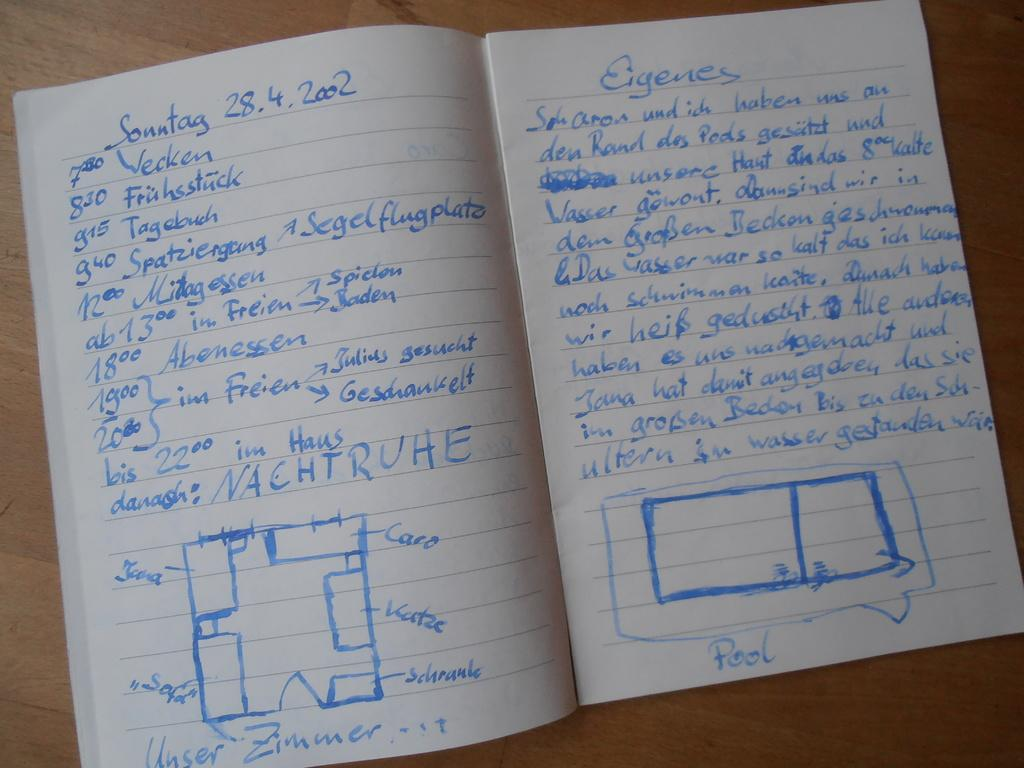<image>
Write a terse but informative summary of the picture. An open notebook with text written in blue ink from Sonntag 28.4.2002 